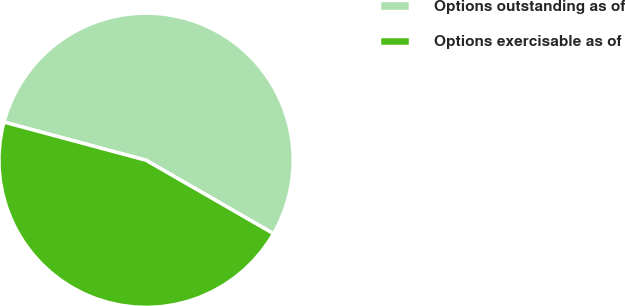Convert chart to OTSL. <chart><loc_0><loc_0><loc_500><loc_500><pie_chart><fcel>Options outstanding as of<fcel>Options exercisable as of<nl><fcel>54.14%<fcel>45.86%<nl></chart> 